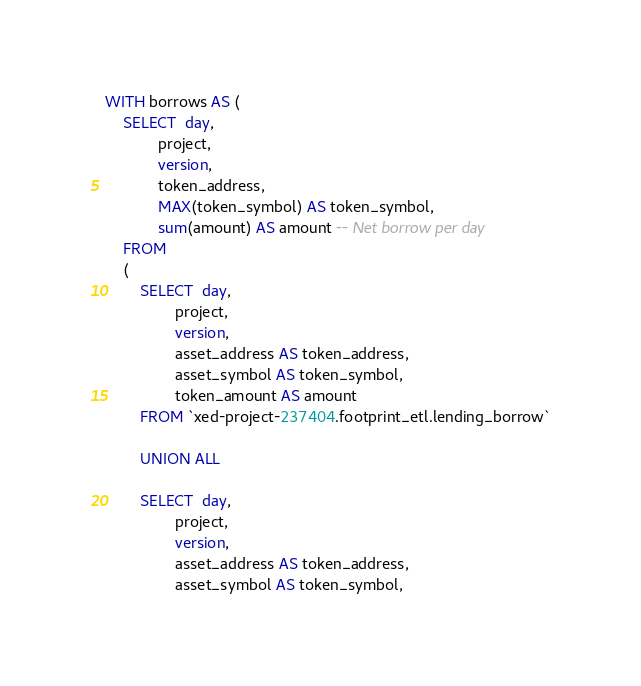<code> <loc_0><loc_0><loc_500><loc_500><_SQL_>WITH borrows AS (
    SELECT  day,
            project,
            version,
            token_address,
            MAX(token_symbol) AS token_symbol,
            sum(amount) AS amount -- Net borrow per day
    FROM
    (
        SELECT  day,
                project,
                version,
                asset_address AS token_address,
                asset_symbol AS token_symbol,
                token_amount AS amount
        FROM `xed-project-237404.footprint_etl.lending_borrow`

        UNION ALL

        SELECT  day,
                project,
                version,
                asset_address AS token_address,
                asset_symbol AS token_symbol,</code> 